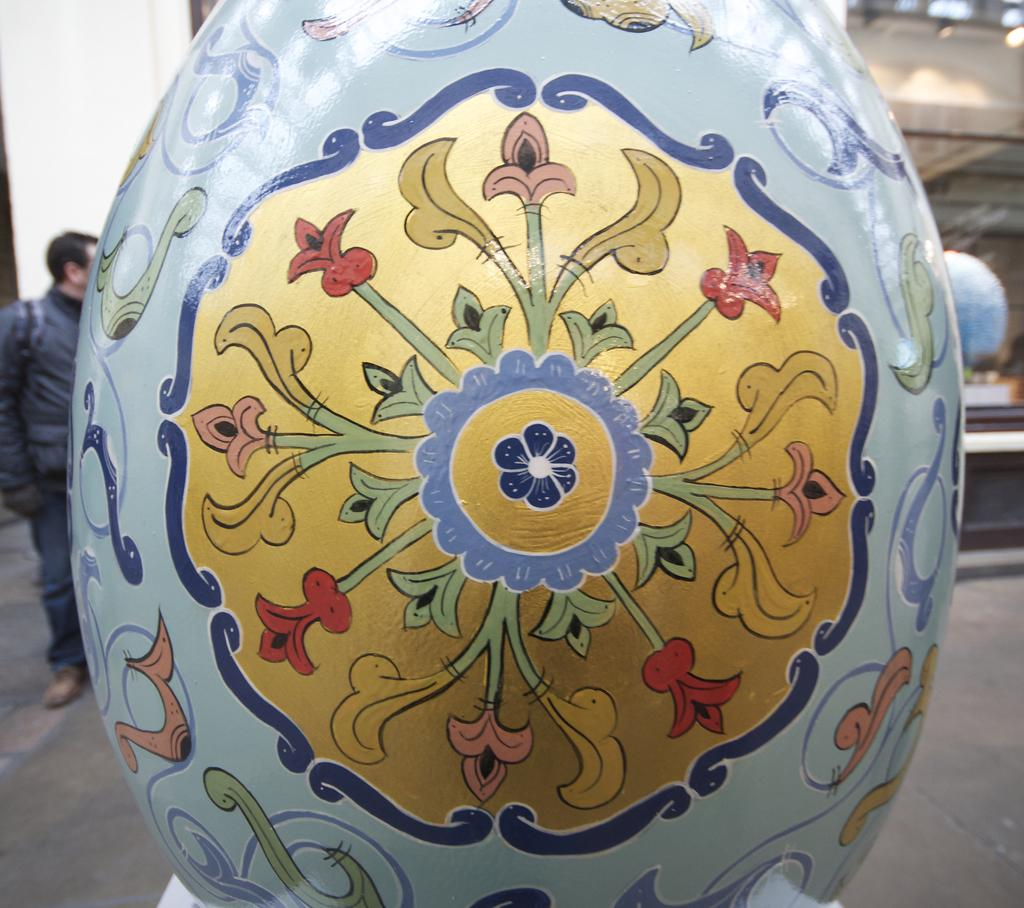What is the main subject of the image? There is an object in the image. What can be seen on the object? The object has a painting of flowers. Who is present in the image besides the object? There is a man standing to the left of the object. What is visible behind the man? There is a wall behind the man. What type of writing can be seen on the object in the image? There is no writing visible on the object in the image; it only has a painting of flowers. What is the man biting in the image? There is no indication in the image that the man is biting anything. 